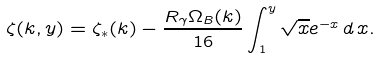Convert formula to latex. <formula><loc_0><loc_0><loc_500><loc_500>\zeta ( k , y ) = \zeta _ { * } ( k ) - \frac { R _ { \gamma } \Omega _ { B } ( k ) } { 1 6 } \int _ { 1 } ^ { y } \sqrt { x } e ^ { - x } \, d \, x .</formula> 